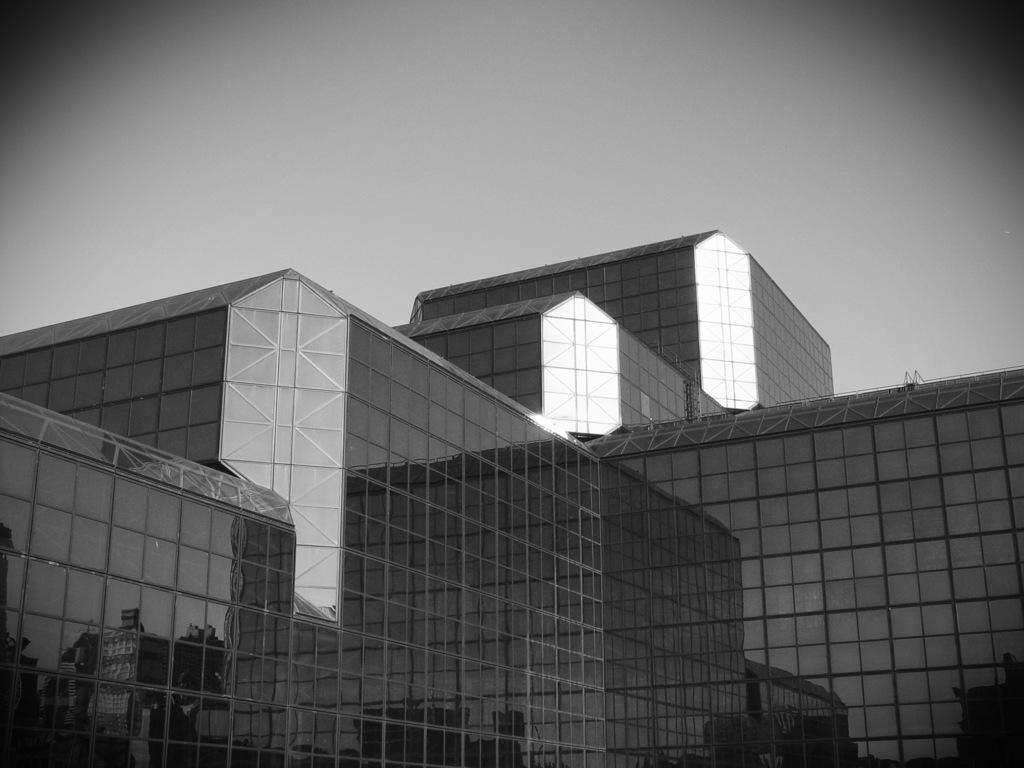What is the color scheme of the image? The image is black and white. What type of structure can be seen in the image? There is a building in the image. What part of the natural environment is visible in the image? The sky is visible in the background of the image. How many wrens can be seen in the image? There are no wrens present in the image, as it is a black and white image of a building with a visible sky in the background. 